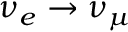Convert formula to latex. <formula><loc_0><loc_0><loc_500><loc_500>\nu _ { e } \rightarrow \nu _ { \mu }</formula> 